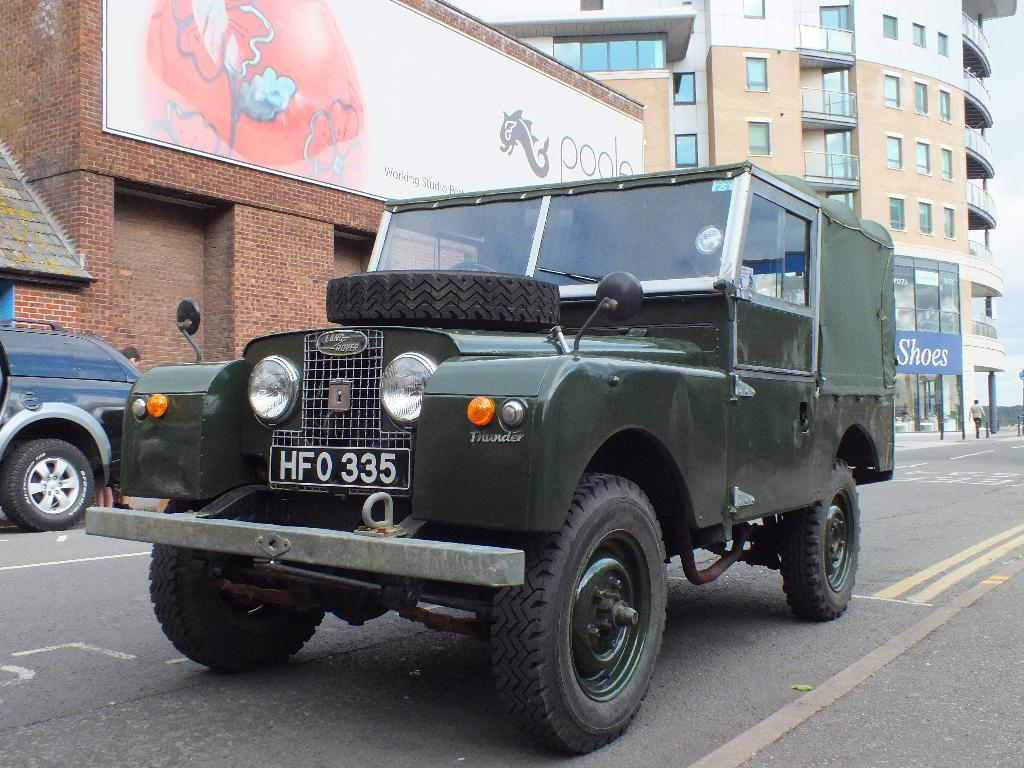What type of vehicle is on the road in the image? There is a jeep on the road in the image. Can you describe any specific part of the jeep? There is a tire visible in the image, possibly belonging to the jeep. What else can be seen in the image besides the jeep? There is a light in the image, possibly on the jeep, as well as buildings, a window glass, and a wall. What type of yarn is being used to decorate the flowers in the image? There are no yarn or flowers present in the image. What season is depicted in the image? The provided facts do not mention any seasonal details, so it cannot be determined from the image. 